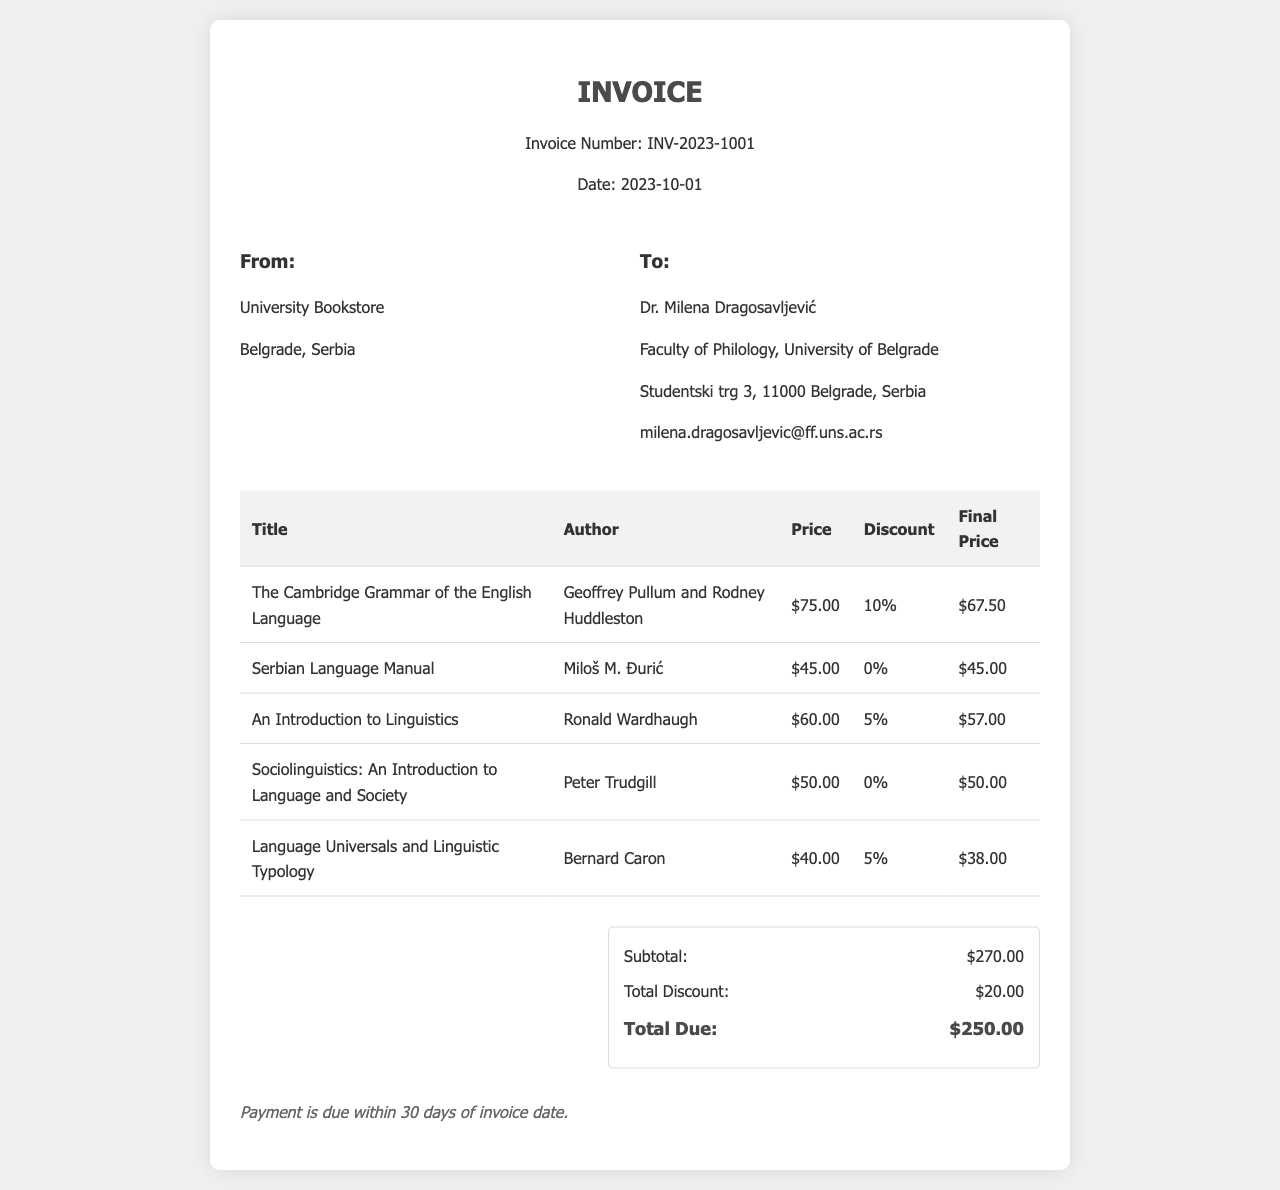What is the invoice number? The invoice number is specified in the header of the document.
Answer: INV-2023-1001 What is the total due amount? The total due amount is calculated in the summary section of the invoice.
Answer: $250.00 Who is the author of "The Cambridge Grammar of the English Language"? The author's name is listed alongside the title in the invoice table.
Answer: Geoffrey Pullum and Rodney Huddleston How much discount was applied to "An Introduction to Linguistics"? The applied discount for the title is indicated in the document.
Answer: 5% What is the price of the "Serbian Language Manual"? The price is specified in the table within the invoice.
Answer: $45.00 What is the subtotal of the invoice? The subtotal is mentioned in the summary details section of the document.
Answer: $270.00 What is the discount total for all items? The total discount is summarized at the end of the invoice.
Answer: $20.00 What is the payment term specified in the invoice? The payment term is stated in the final section of the invoice.
Answer: Payment is due within 30 days of invoice date 